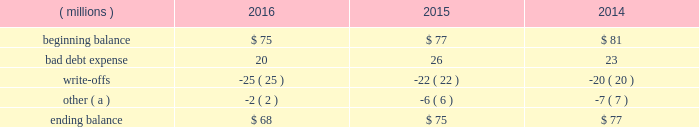Cash and cash equivalents cash equivalents include highly-liquid investments with a maturity of three months or less when purchased .
Accounts receivable and allowance for doubtful accounts accounts receivable are carried at the invoiced amounts , less an allowance for doubtful accounts , and generally do not bear interest .
The company estimates the balance of allowance for doubtful accounts by analyzing accounts receivable balances by age and applying historical write-off and collection trend rates .
The company 2019s estimates include separately providing for customer receivables based on specific circumstances and credit conditions , and when it is deemed probable that the balance is uncollectible .
Account balances are charged off against the allowance when it is determined the receivable will not be recovered .
The company 2019s allowance for doubtful accounts balance also includes an allowance for the expected return of products shipped and credits related to pricing or quantities shipped of $ 14 million , $ 15 million and $ 14 million as of december 31 , 2016 , 2015 , and 2014 , respectively .
Returns and credit activity is recorded directly to sales as a reduction .
The table summarizes the activity in the allowance for doubtful accounts: .
( a ) other amounts are primarily the effects of changes in currency translations and the impact of allowance for returns and credits .
Inventory valuations inventories are valued at the lower of cost or market .
Certain u.s .
Inventory costs are determined on a last-in , first-out ( 201clifo 201d ) basis .
Lifo inventories represented 40% ( 40 % ) and 39% ( 39 % ) of consolidated inventories as of december 31 , 2016 and 2015 , respectively .
Lifo inventories include certain legacy nalco u.s .
Inventory acquired at fair value as part of the nalco merger .
All other inventory costs are determined using either the average cost or first-in , first-out ( 201cfifo 201d ) methods .
Inventory values at fifo , as shown in note 5 , approximate replacement cost .
During 2015 , the company improved and standardized estimates related to its inventory reserves and product costing , resulting in a net pre-tax charge of approximately $ 6 million .
Separately , the actions resulted in a charge of $ 20.6 million related to inventory reserve calculations , partially offset by a gain of $ 14.5 million related to the capitalization of certain cost components into inventory .
During 2016 , the company took additional actions to improve and standardize estimates related to the capitalization of certain cost components into inventory , which resulted in a gain of $ 6.2 million .
These items are reflected within special ( gains ) and charges , as discussed in note 3 .
Property , plant and equipment property , plant and equipment assets are stated at cost .
Merchandising and customer equipment consists principally of various dispensing systems for the company 2019s cleaning and sanitizing products , dishwashing machines and process control and monitoring equipment .
Certain dispensing systems capitalized by the company are accounted for on a mass asset basis , whereby equipment is capitalized and depreciated as a group and written off when fully depreciated .
The company capitalizes both internal and external costs of development or purchase of computer software for internal use .
Costs incurred for data conversion , training and maintenance associated with capitalized software are expensed as incurred .
Expenditures for major renewals and improvements , which significantly extend the useful lives of existing plant and equipment , are capitalized and depreciated .
Expenditures for repairs and maintenance are charged to expense as incurred .
Upon retirement or disposition of plant and equipment , the cost and related accumulated depreciation are removed from the accounts and any resulting gain or loss is recognized in income .
Depreciation is charged to operations using the straight-line method over the assets 2019 estimated useful lives ranging from 5 to 40 years for buildings and leasehold improvements , 3 to 20 years for machinery and equipment , 3 to 15 years for merchandising and customer equipment and 3 to 7 years for capitalized software .
The straight-line method of depreciation reflects an appropriate allocation of the cost of the assets to earnings in proportion to the amount of economic benefits obtained by the company in each reporting period .
Depreciation expense was $ 561 million , $ 560 million and $ 558 million for 2016 , 2015 and 2014 , respectively. .
In millions for 2016 , 2015 , and 2014 , what was the total beginning balance in allowance for doubtful accounts? 
Computations: table_sum(beginning balance, none)
Answer: 233.0. 